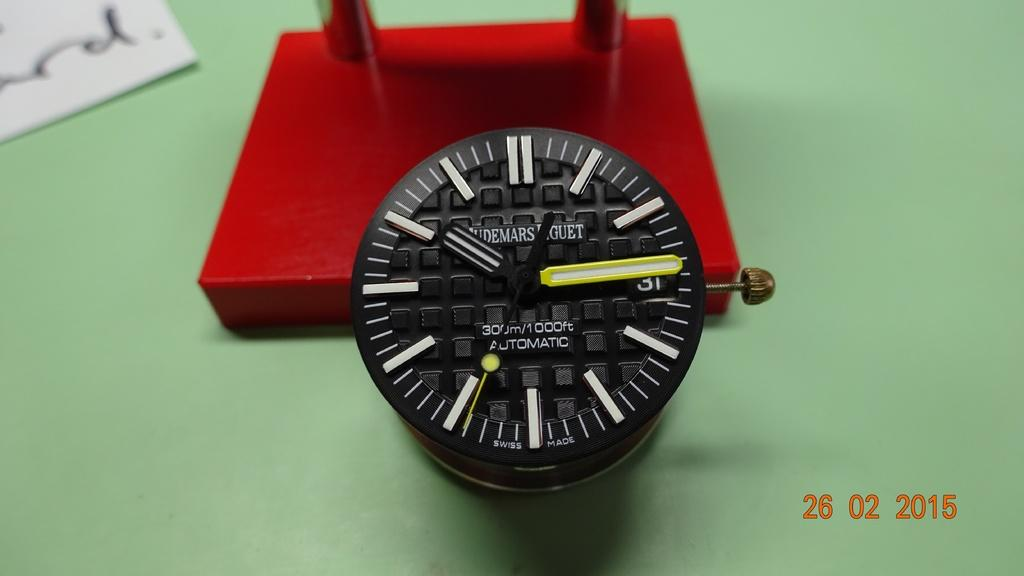<image>
Give a short and clear explanation of the subsequent image. A black face of a watch that has states 300 m/1000 Automatic on the front of the watch face. 